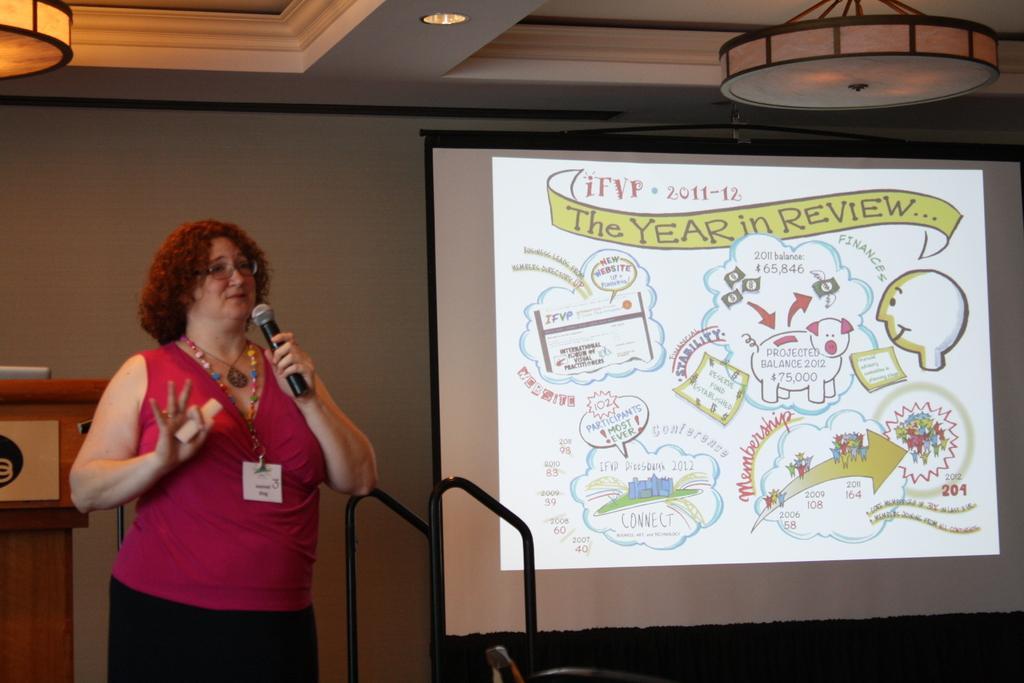Could you give a brief overview of what you see in this image? On the left side, we see a woman in the pink and black dress is stunning. She is wearing the spectacles. She is holding a microphone in one of her hands and in the other hand, she is holding an object. Behind her, we see a podium on which a laptop is placed. On the right side, we see the projector screen which is displaying some text. Beside that, we see the iron rods. In the background, we see a white wall. At the top, we see the ceiling of the room. 